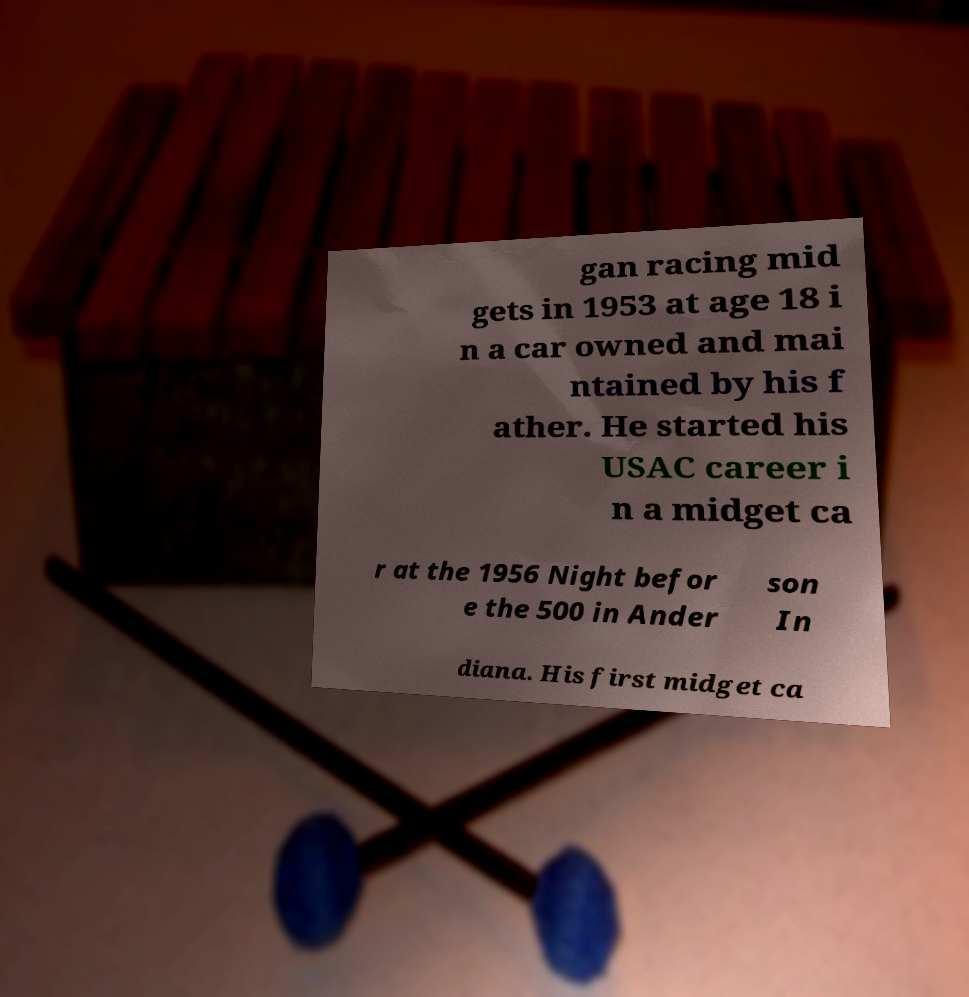Please identify and transcribe the text found in this image. gan racing mid gets in 1953 at age 18 i n a car owned and mai ntained by his f ather. He started his USAC career i n a midget ca r at the 1956 Night befor e the 500 in Ander son In diana. His first midget ca 